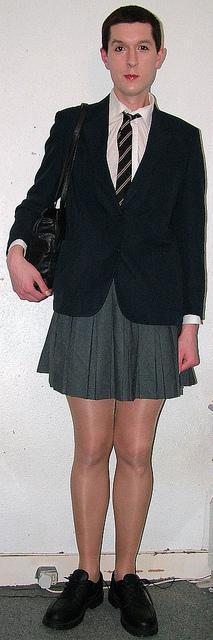How many people are visible?
Give a very brief answer. 1. 